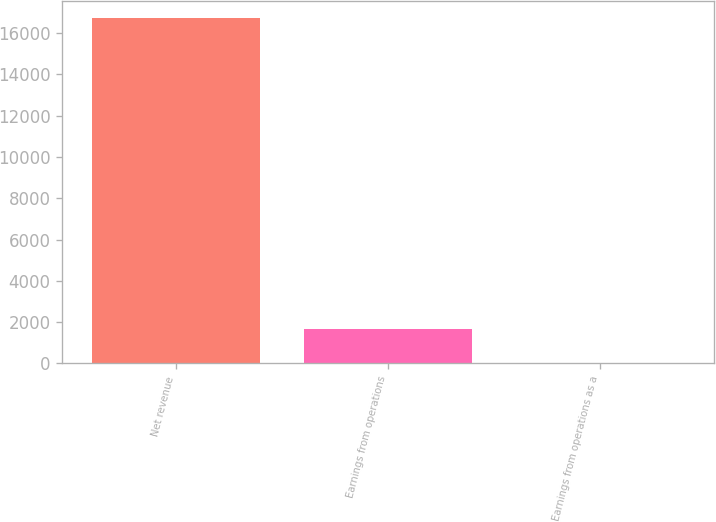<chart> <loc_0><loc_0><loc_500><loc_500><bar_chart><fcel>Net revenue<fcel>Earnings from operations<fcel>Earnings from operations as a<nl><fcel>16717<fcel>1676.02<fcel>4.8<nl></chart> 